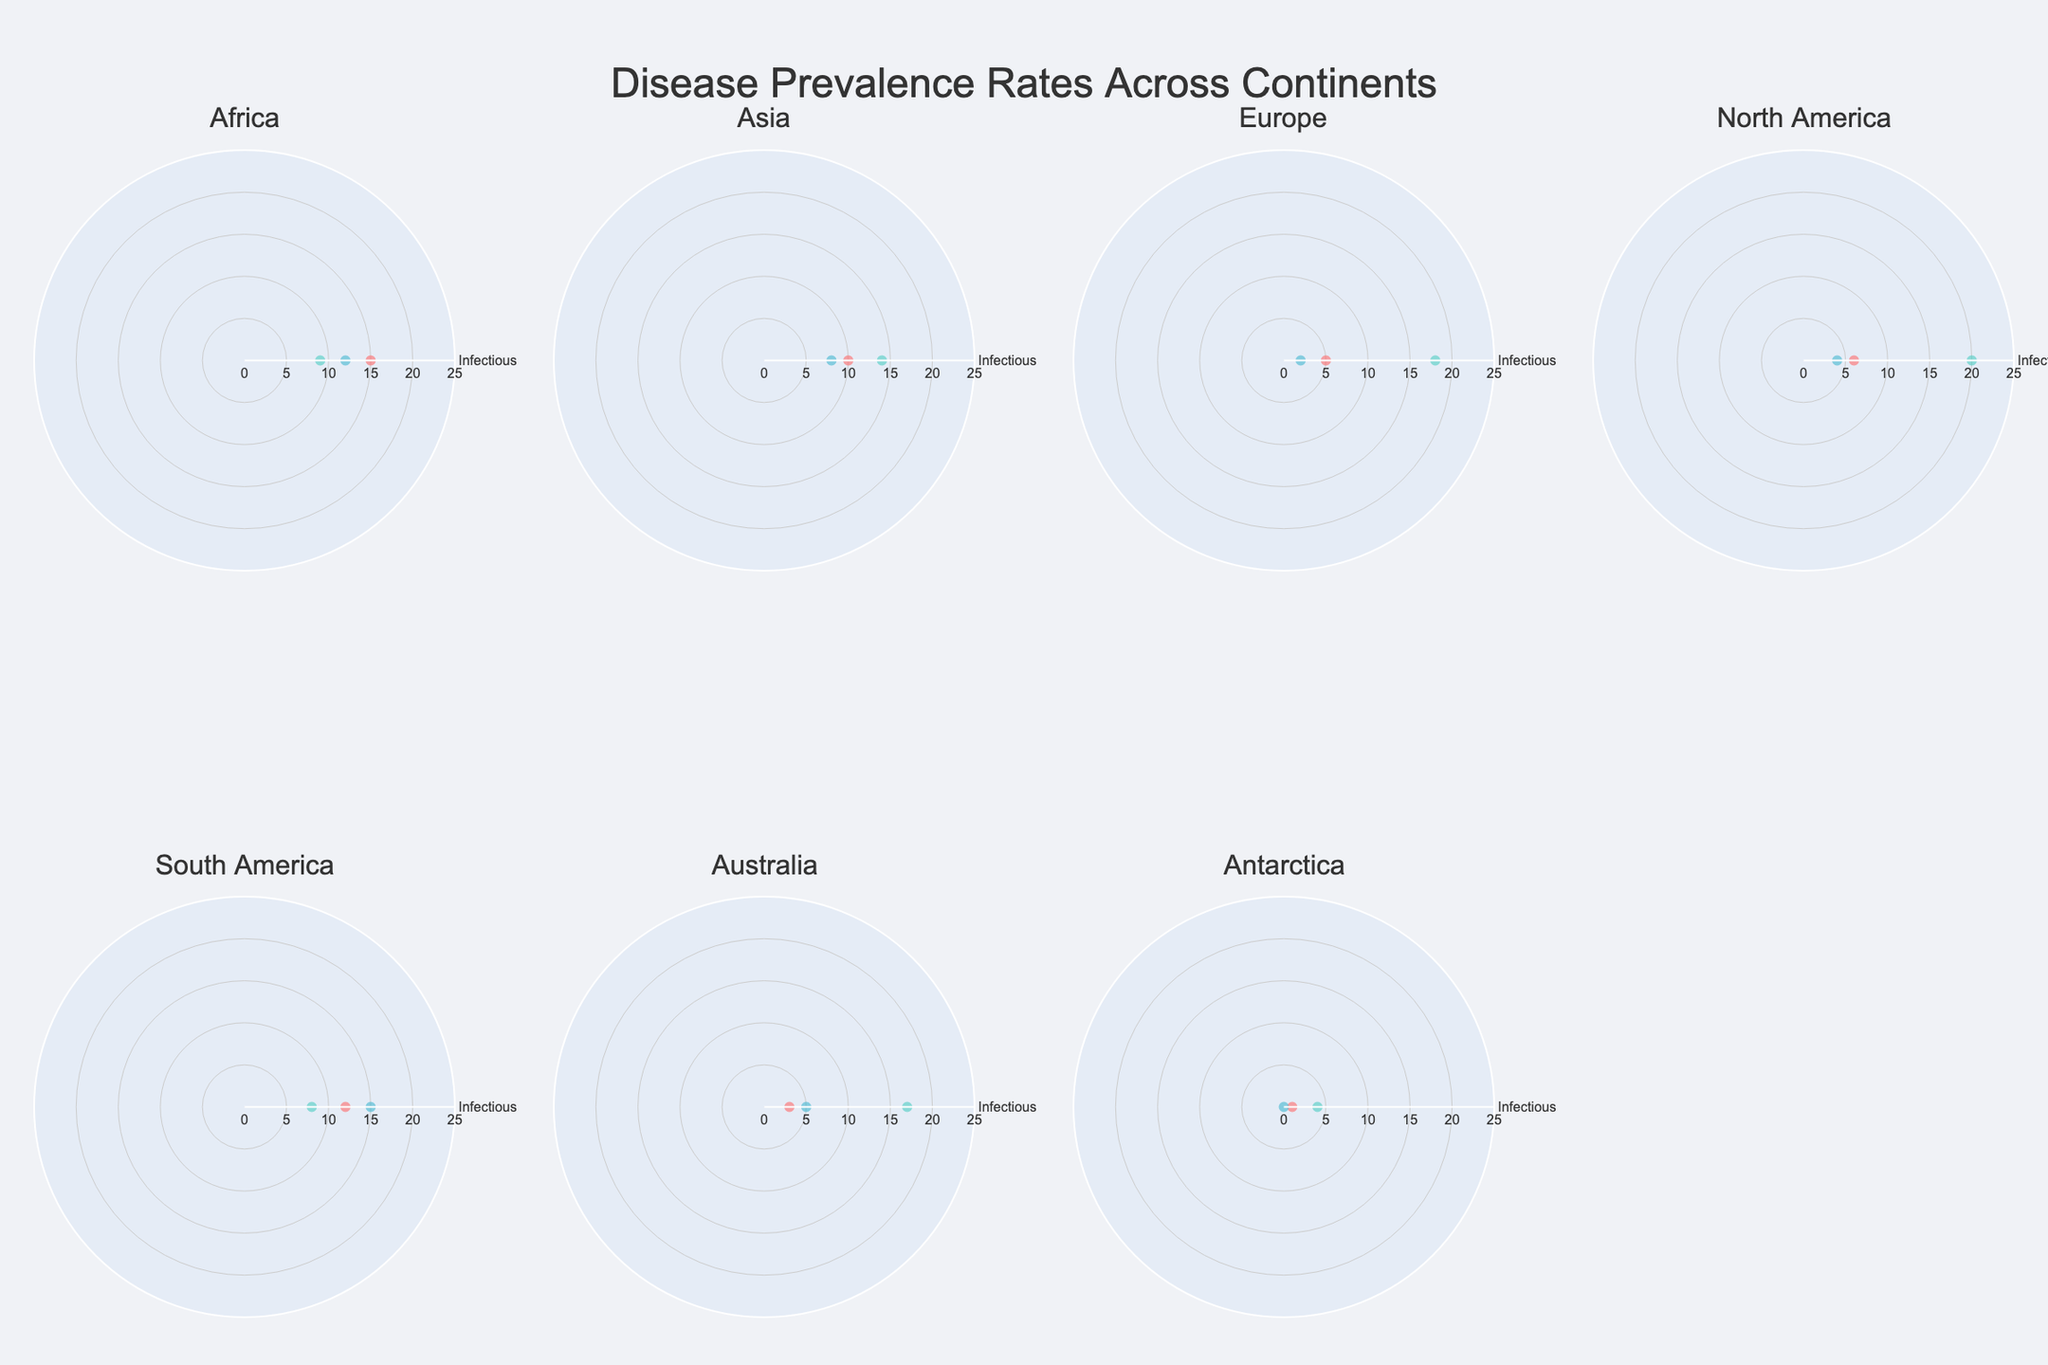Which continent has the highest prevalence rate for non-infectious diseases? By examining each subplot, North America's radar chart shows the highest spike for non-infectious diseases.
Answer: North America Which type of disease has the lowest prevalence rate in Europe? By checking the values for Europe, vector-borne diseases show the lowest value.
Answer: Vector-Borne What are the three prevalence rates for diseases in Africa? Referring to Africa's subplot, the values are 15 for infectious, 9 for non-infectious, and 12 for vector-borne.
Answer: 15, 9, 12 Which disease type's prevalence rate is highest in South America? In South America's radar chart, vector-borne diseases have the highest prevalence rate.
Answer: Vector-Borne Compare the prevalence rates of vector-borne diseases in Africa and Australia. Which continent has a higher rate? Africa has a vector-borne disease rate of 12, while Australia has a rate of 5. Thus, Africa is higher.
Answer: Africa What is the average prevalence rate for non-infectious diseases across all continents? Sum the non-infectious prevalence rates (9 + 14 + 18 + 20 + 8 + 17 + 4 = 90) and divide by the number of continents (7). 90 / 7 = 12.86.
Answer: 12.86 In which continent is the difference between the prevalence rates of infectious and non-infectious diseases the greatest? Calculate the differences: Africa (6), Asia (4), Europe (13), North America (14), South America (4), Australia (14), Antarctica (3). North America and Australia both have the highest difference of 14.
Answer: North America, Australia Which continent has the most balanced prevalence rates among the three disease types? By comparing the radar charts, Africa’s rates (15, 9, 12) are relatively balanced compared to other continents where there are strong spikes in one or more types.
Answer: Africa How does Europe’s prevalence rate for infectious diseases compare to Antarctica's? Europe's rate is 5, while Antarctica's is 1. Therefore, Europe's rate is higher.
Answer: Europe 